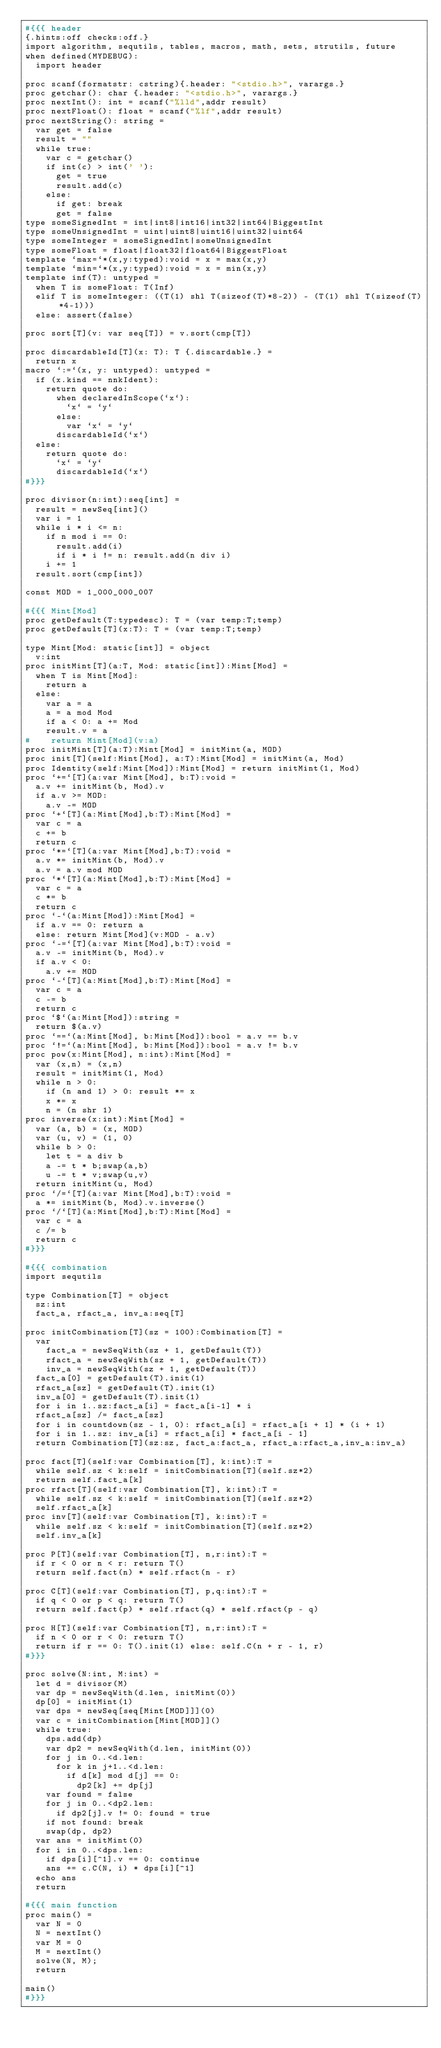Convert code to text. <code><loc_0><loc_0><loc_500><loc_500><_Nim_>#{{{ header
{.hints:off checks:off.}
import algorithm, sequtils, tables, macros, math, sets, strutils, future
when defined(MYDEBUG):
  import header

proc scanf(formatstr: cstring){.header: "<stdio.h>", varargs.}
proc getchar(): char {.header: "<stdio.h>", varargs.}
proc nextInt(): int = scanf("%lld",addr result)
proc nextFloat(): float = scanf("%lf",addr result)
proc nextString(): string =
  var get = false
  result = ""
  while true:
    var c = getchar()
    if int(c) > int(' '):
      get = true
      result.add(c)
    else:
      if get: break
      get = false
type someSignedInt = int|int8|int16|int32|int64|BiggestInt
type someUnsignedInt = uint|uint8|uint16|uint32|uint64
type someInteger = someSignedInt|someUnsignedInt
type someFloat = float|float32|float64|BiggestFloat
template `max=`*(x,y:typed):void = x = max(x,y)
template `min=`*(x,y:typed):void = x = min(x,y)
template inf(T): untyped = 
  when T is someFloat: T(Inf)
  elif T is someInteger: ((T(1) shl T(sizeof(T)*8-2)) - (T(1) shl T(sizeof(T)*4-1)))
  else: assert(false)

proc sort[T](v: var seq[T]) = v.sort(cmp[T])

proc discardableId[T](x: T): T {.discardable.} =
  return x
macro `:=`(x, y: untyped): untyped =
  if (x.kind == nnkIdent):
    return quote do:
      when declaredInScope(`x`):
        `x` = `y`
      else:
        var `x` = `y`
      discardableId(`x`)
  else:
    return quote do:
      `x` = `y`
      discardableId(`x`)
#}}}

proc divisor(n:int):seq[int] =
  result = newSeq[int]()
  var i = 1
  while i * i <= n:
    if n mod i == 0:
      result.add(i)
      if i * i != n: result.add(n div i)
    i += 1
  result.sort(cmp[int])

const MOD = 1_000_000_007

#{{{ Mint[Mod]
proc getDefault(T:typedesc): T = (var temp:T;temp)
proc getDefault[T](x:T): T = (var temp:T;temp)

type Mint[Mod: static[int]] = object
  v:int
proc initMint[T](a:T, Mod: static[int]):Mint[Mod] =
  when T is Mint[Mod]:
    return a
  else:
    var a = a
    a = a mod Mod
    if a < 0: a += Mod
    result.v = a
#    return Mint[Mod](v:a)
proc initMint[T](a:T):Mint[Mod] = initMint(a, MOD)
proc init[T](self:Mint[Mod], a:T):Mint[Mod] = initMint(a, Mod)
proc Identity(self:Mint[Mod]):Mint[Mod] = return initMint(1, Mod)
proc `+=`[T](a:var Mint[Mod], b:T):void =
  a.v += initMint(b, Mod).v
  if a.v >= MOD:
    a.v -= MOD
proc `+`[T](a:Mint[Mod],b:T):Mint[Mod] =
  var c = a
  c += b
  return c
proc `*=`[T](a:var Mint[Mod],b:T):void =
  a.v *= initMint(b, Mod).v
  a.v = a.v mod MOD
proc `*`[T](a:Mint[Mod],b:T):Mint[Mod] =
  var c = a
  c *= b
  return c
proc `-`(a:Mint[Mod]):Mint[Mod] =
  if a.v == 0: return a
  else: return Mint[Mod](v:MOD - a.v)
proc `-=`[T](a:var Mint[Mod],b:T):void =
  a.v -= initMint(b, Mod).v
  if a.v < 0:
    a.v += MOD
proc `-`[T](a:Mint[Mod],b:T):Mint[Mod] =
  var c = a
  c -= b
  return c
proc `$`(a:Mint[Mod]):string =
  return $(a.v)
proc `==`(a:Mint[Mod], b:Mint[Mod]):bool = a.v == b.v
proc `!=`(a:Mint[Mod], b:Mint[Mod]):bool = a.v != b.v
proc pow(x:Mint[Mod], n:int):Mint[Mod] =
  var (x,n) = (x,n)
  result = initMint(1, Mod)
  while n > 0:
    if (n and 1) > 0: result *= x
    x *= x
    n = (n shr 1)
proc inverse(x:int):Mint[Mod] =
  var (a, b) = (x, MOD)
  var (u, v) = (1, 0)
  while b > 0:
    let t = a div b
    a -= t * b;swap(a,b)
    u -= t * v;swap(u,v)
  return initMint(u, Mod)
proc `/=`[T](a:var Mint[Mod],b:T):void =
  a *= initMint(b, Mod).v.inverse()
proc `/`[T](a:Mint[Mod],b:T):Mint[Mod] =
  var c = a
  c /= b
  return c
#}}}

#{{{ combination
import sequtils

type Combination[T] = object
  sz:int
  fact_a, rfact_a, inv_a:seq[T]

proc initCombination[T](sz = 100):Combination[T] = 
  var
    fact_a = newSeqWith(sz + 1, getDefault(T))
    rfact_a = newSeqWith(sz + 1, getDefault(T))
    inv_a = newSeqWith(sz + 1, getDefault(T))
  fact_a[0] = getDefault(T).init(1)
  rfact_a[sz] = getDefault(T).init(1)
  inv_a[0] = getDefault(T).init(1)
  for i in 1..sz:fact_a[i] = fact_a[i-1] * i
  rfact_a[sz] /= fact_a[sz]
  for i in countdown(sz - 1, 0): rfact_a[i] = rfact_a[i + 1] * (i + 1)
  for i in 1..sz: inv_a[i] = rfact_a[i] * fact_a[i - 1]
  return Combination[T](sz:sz, fact_a:fact_a, rfact_a:rfact_a,inv_a:inv_a)

proc fact[T](self:var Combination[T], k:int):T =
  while self.sz < k:self = initCombination[T](self.sz*2)
  return self.fact_a[k]
proc rfact[T](self:var Combination[T], k:int):T =
  while self.sz < k:self = initCombination[T](self.sz*2)
  self.rfact_a[k]
proc inv[T](self:var Combination[T], k:int):T =
  while self.sz < k:self = initCombination[T](self.sz*2)
  self.inv_a[k]

proc P[T](self:var Combination[T], n,r:int):T =
  if r < 0 or n < r: return T()
  return self.fact(n) * self.rfact(n - r)

proc C[T](self:var Combination[T], p,q:int):T =
  if q < 0 or p < q: return T()
  return self.fact(p) * self.rfact(q) * self.rfact(p - q)

proc H[T](self:var Combination[T], n,r:int):T =
  if n < 0 or r < 0: return T()
  return if r == 0: T().init(1) else: self.C(n + r - 1, r)
#}}}

proc solve(N:int, M:int) =
  let d = divisor(M)
  var dp = newSeqWith(d.len, initMint(0))
  dp[0] = initMint(1)
  var dps = newSeq[seq[Mint[MOD]]](0)
  var c = initCombination[Mint[MOD]]()
  while true:
    dps.add(dp)
    var dp2 = newSeqWith(d.len, initMint(0))
    for j in 0..<d.len:
      for k in j+1..<d.len:
        if d[k] mod d[j] == 0:
          dp2[k] += dp[j]
    var found = false
    for j in 0..<dp2.len:
      if dp2[j].v != 0: found = true
    if not found: break
    swap(dp, dp2)
  var ans = initMint(0)
  for i in 0..<dps.len:
    if dps[i][^1].v == 0: continue
    ans += c.C(N, i) * dps[i][^1]
  echo ans
  return

#{{{ main function
proc main() =
  var N = 0
  N = nextInt()
  var M = 0
  M = nextInt()
  solve(N, M);
  return

main()
#}}}
</code> 